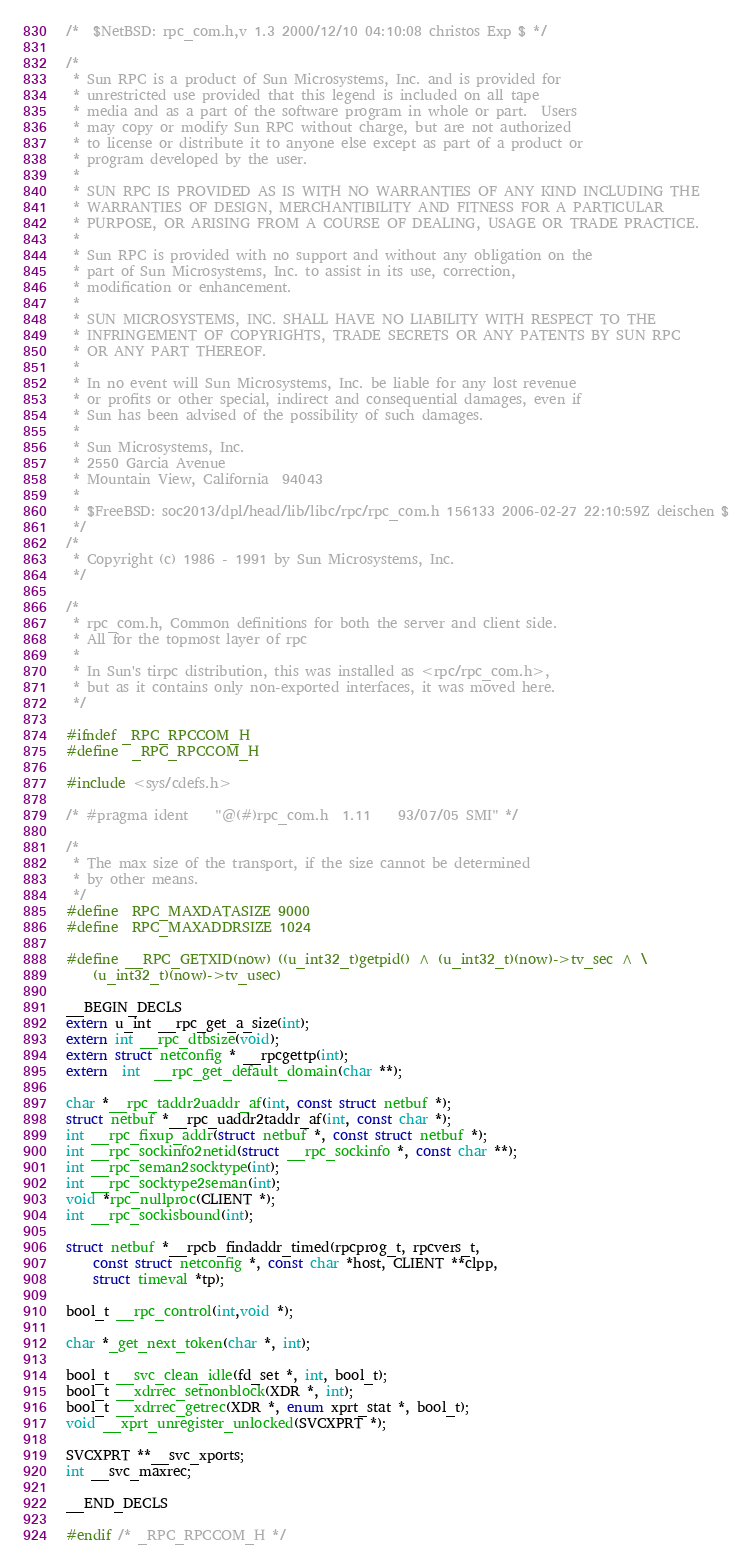Convert code to text. <code><loc_0><loc_0><loc_500><loc_500><_C_>/*	$NetBSD: rpc_com.h,v 1.3 2000/12/10 04:10:08 christos Exp $	*/

/*
 * Sun RPC is a product of Sun Microsystems, Inc. and is provided for
 * unrestricted use provided that this legend is included on all tape
 * media and as a part of the software program in whole or part.  Users
 * may copy or modify Sun RPC without charge, but are not authorized
 * to license or distribute it to anyone else except as part of a product or
 * program developed by the user.
 * 
 * SUN RPC IS PROVIDED AS IS WITH NO WARRANTIES OF ANY KIND INCLUDING THE
 * WARRANTIES OF DESIGN, MERCHANTIBILITY AND FITNESS FOR A PARTICULAR
 * PURPOSE, OR ARISING FROM A COURSE OF DEALING, USAGE OR TRADE PRACTICE.
 * 
 * Sun RPC is provided with no support and without any obligation on the
 * part of Sun Microsystems, Inc. to assist in its use, correction,
 * modification or enhancement.
 * 
 * SUN MICROSYSTEMS, INC. SHALL HAVE NO LIABILITY WITH RESPECT TO THE
 * INFRINGEMENT OF COPYRIGHTS, TRADE SECRETS OR ANY PATENTS BY SUN RPC
 * OR ANY PART THEREOF.
 * 
 * In no event will Sun Microsystems, Inc. be liable for any lost revenue
 * or profits or other special, indirect and consequential damages, even if
 * Sun has been advised of the possibility of such damages.
 * 
 * Sun Microsystems, Inc.
 * 2550 Garcia Avenue
 * Mountain View, California  94043
 *
 * $FreeBSD: soc2013/dpl/head/lib/libc/rpc/rpc_com.h 156133 2006-02-27 22:10:59Z deischen $
 */
/*
 * Copyright (c) 1986 - 1991 by Sun Microsystems, Inc.
 */

/*
 * rpc_com.h, Common definitions for both the server and client side.
 * All for the topmost layer of rpc
 *
 * In Sun's tirpc distribution, this was installed as <rpc/rpc_com.h>,
 * but as it contains only non-exported interfaces, it was moved here.
 */

#ifndef _RPC_RPCCOM_H
#define	_RPC_RPCCOM_H

#include <sys/cdefs.h>

/* #pragma ident	"@(#)rpc_com.h	1.11	93/07/05 SMI" */

/*
 * The max size of the transport, if the size cannot be determined
 * by other means.
 */
#define	RPC_MAXDATASIZE 9000
#define	RPC_MAXADDRSIZE 1024

#define __RPC_GETXID(now) ((u_int32_t)getpid() ^ (u_int32_t)(now)->tv_sec ^ \
    (u_int32_t)(now)->tv_usec)

__BEGIN_DECLS
extern u_int __rpc_get_a_size(int);
extern int __rpc_dtbsize(void);
extern struct netconfig * __rpcgettp(int);
extern  int  __rpc_get_default_domain(char **);

char *__rpc_taddr2uaddr_af(int, const struct netbuf *);
struct netbuf *__rpc_uaddr2taddr_af(int, const char *);
int __rpc_fixup_addr(struct netbuf *, const struct netbuf *);
int __rpc_sockinfo2netid(struct __rpc_sockinfo *, const char **);
int __rpc_seman2socktype(int);
int __rpc_socktype2seman(int);
void *rpc_nullproc(CLIENT *);
int __rpc_sockisbound(int);

struct netbuf *__rpcb_findaddr_timed(rpcprog_t, rpcvers_t,
    const struct netconfig *, const char *host, CLIENT **clpp,
    struct timeval *tp);

bool_t __rpc_control(int,void *);

char *_get_next_token(char *, int);

bool_t __svc_clean_idle(fd_set *, int, bool_t);
bool_t __xdrrec_setnonblock(XDR *, int);
bool_t __xdrrec_getrec(XDR *, enum xprt_stat *, bool_t);
void __xprt_unregister_unlocked(SVCXPRT *);

SVCXPRT **__svc_xports;
int __svc_maxrec;

__END_DECLS

#endif /* _RPC_RPCCOM_H */
</code> 